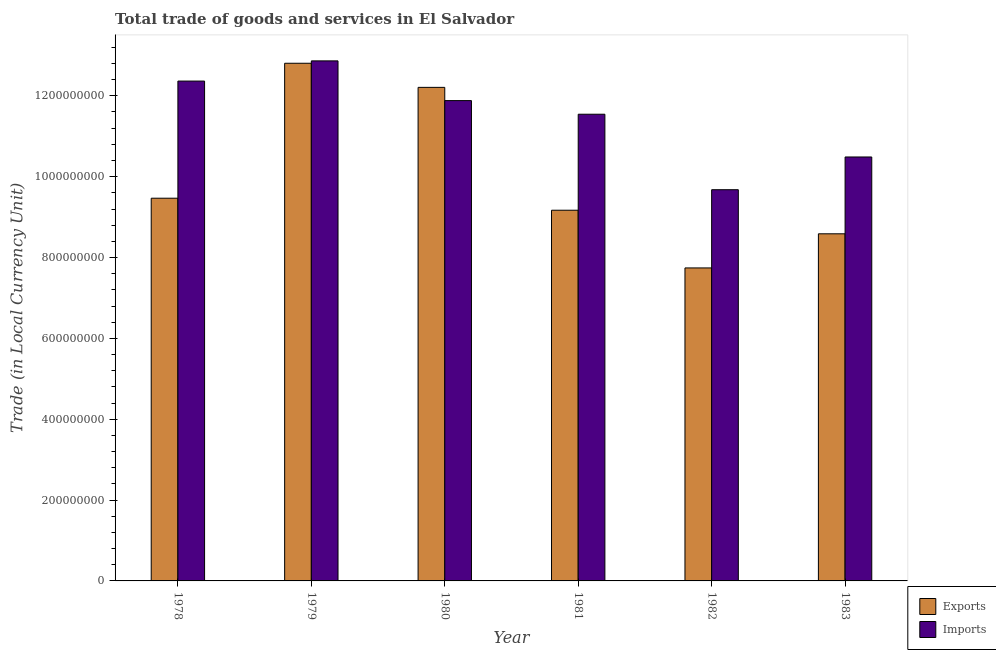How many different coloured bars are there?
Your response must be concise. 2. How many groups of bars are there?
Provide a succinct answer. 6. Are the number of bars per tick equal to the number of legend labels?
Your response must be concise. Yes. Are the number of bars on each tick of the X-axis equal?
Provide a succinct answer. Yes. How many bars are there on the 3rd tick from the right?
Your answer should be very brief. 2. What is the label of the 2nd group of bars from the left?
Provide a short and direct response. 1979. In how many cases, is the number of bars for a given year not equal to the number of legend labels?
Provide a succinct answer. 0. What is the export of goods and services in 1979?
Offer a terse response. 1.28e+09. Across all years, what is the maximum export of goods and services?
Your answer should be compact. 1.28e+09. Across all years, what is the minimum export of goods and services?
Offer a very short reply. 7.74e+08. In which year was the export of goods and services maximum?
Offer a terse response. 1979. In which year was the imports of goods and services minimum?
Make the answer very short. 1982. What is the total export of goods and services in the graph?
Offer a terse response. 6.00e+09. What is the difference between the imports of goods and services in 1978 and that in 1983?
Offer a very short reply. 1.88e+08. What is the difference between the export of goods and services in 1980 and the imports of goods and services in 1982?
Provide a succinct answer. 4.47e+08. What is the average imports of goods and services per year?
Offer a terse response. 1.15e+09. In the year 1980, what is the difference between the export of goods and services and imports of goods and services?
Offer a terse response. 0. In how many years, is the imports of goods and services greater than 240000000 LCU?
Give a very brief answer. 6. What is the ratio of the export of goods and services in 1979 to that in 1981?
Give a very brief answer. 1.4. Is the export of goods and services in 1978 less than that in 1983?
Offer a very short reply. No. What is the difference between the highest and the second highest export of goods and services?
Keep it short and to the point. 5.96e+07. What is the difference between the highest and the lowest export of goods and services?
Your response must be concise. 5.06e+08. In how many years, is the export of goods and services greater than the average export of goods and services taken over all years?
Your answer should be very brief. 2. What does the 1st bar from the left in 1978 represents?
Your answer should be very brief. Exports. What does the 1st bar from the right in 1981 represents?
Provide a succinct answer. Imports. Are all the bars in the graph horizontal?
Provide a short and direct response. No. Are the values on the major ticks of Y-axis written in scientific E-notation?
Give a very brief answer. No. How many legend labels are there?
Give a very brief answer. 2. How are the legend labels stacked?
Your response must be concise. Vertical. What is the title of the graph?
Your response must be concise. Total trade of goods and services in El Salvador. Does "Formally registered" appear as one of the legend labels in the graph?
Provide a short and direct response. No. What is the label or title of the Y-axis?
Make the answer very short. Trade (in Local Currency Unit). What is the Trade (in Local Currency Unit) in Exports in 1978?
Keep it short and to the point. 9.47e+08. What is the Trade (in Local Currency Unit) in Imports in 1978?
Offer a very short reply. 1.24e+09. What is the Trade (in Local Currency Unit) in Exports in 1979?
Keep it short and to the point. 1.28e+09. What is the Trade (in Local Currency Unit) of Imports in 1979?
Ensure brevity in your answer.  1.29e+09. What is the Trade (in Local Currency Unit) of Exports in 1980?
Your answer should be very brief. 1.22e+09. What is the Trade (in Local Currency Unit) of Imports in 1980?
Offer a terse response. 1.19e+09. What is the Trade (in Local Currency Unit) in Exports in 1981?
Make the answer very short. 9.17e+08. What is the Trade (in Local Currency Unit) in Imports in 1981?
Your answer should be compact. 1.15e+09. What is the Trade (in Local Currency Unit) in Exports in 1982?
Your answer should be compact. 7.74e+08. What is the Trade (in Local Currency Unit) of Imports in 1982?
Ensure brevity in your answer.  9.68e+08. What is the Trade (in Local Currency Unit) of Exports in 1983?
Offer a very short reply. 8.59e+08. What is the Trade (in Local Currency Unit) in Imports in 1983?
Your response must be concise. 1.05e+09. Across all years, what is the maximum Trade (in Local Currency Unit) of Exports?
Your answer should be very brief. 1.28e+09. Across all years, what is the maximum Trade (in Local Currency Unit) in Imports?
Provide a short and direct response. 1.29e+09. Across all years, what is the minimum Trade (in Local Currency Unit) of Exports?
Your answer should be compact. 7.74e+08. Across all years, what is the minimum Trade (in Local Currency Unit) of Imports?
Give a very brief answer. 9.68e+08. What is the total Trade (in Local Currency Unit) of Exports in the graph?
Make the answer very short. 6.00e+09. What is the total Trade (in Local Currency Unit) of Imports in the graph?
Give a very brief answer. 6.88e+09. What is the difference between the Trade (in Local Currency Unit) of Exports in 1978 and that in 1979?
Give a very brief answer. -3.34e+08. What is the difference between the Trade (in Local Currency Unit) in Imports in 1978 and that in 1979?
Make the answer very short. -5.00e+07. What is the difference between the Trade (in Local Currency Unit) of Exports in 1978 and that in 1980?
Keep it short and to the point. -2.74e+08. What is the difference between the Trade (in Local Currency Unit) of Imports in 1978 and that in 1980?
Make the answer very short. 4.83e+07. What is the difference between the Trade (in Local Currency Unit) in Exports in 1978 and that in 1981?
Ensure brevity in your answer.  2.97e+07. What is the difference between the Trade (in Local Currency Unit) of Imports in 1978 and that in 1981?
Keep it short and to the point. 8.20e+07. What is the difference between the Trade (in Local Currency Unit) of Exports in 1978 and that in 1982?
Provide a short and direct response. 1.72e+08. What is the difference between the Trade (in Local Currency Unit) in Imports in 1978 and that in 1982?
Make the answer very short. 2.69e+08. What is the difference between the Trade (in Local Currency Unit) in Exports in 1978 and that in 1983?
Offer a very short reply. 8.81e+07. What is the difference between the Trade (in Local Currency Unit) in Imports in 1978 and that in 1983?
Your answer should be compact. 1.88e+08. What is the difference between the Trade (in Local Currency Unit) of Exports in 1979 and that in 1980?
Ensure brevity in your answer.  5.96e+07. What is the difference between the Trade (in Local Currency Unit) of Imports in 1979 and that in 1980?
Ensure brevity in your answer.  9.83e+07. What is the difference between the Trade (in Local Currency Unit) of Exports in 1979 and that in 1981?
Provide a succinct answer. 3.64e+08. What is the difference between the Trade (in Local Currency Unit) of Imports in 1979 and that in 1981?
Keep it short and to the point. 1.32e+08. What is the difference between the Trade (in Local Currency Unit) of Exports in 1979 and that in 1982?
Give a very brief answer. 5.06e+08. What is the difference between the Trade (in Local Currency Unit) in Imports in 1979 and that in 1982?
Give a very brief answer. 3.19e+08. What is the difference between the Trade (in Local Currency Unit) in Exports in 1979 and that in 1983?
Your answer should be very brief. 4.22e+08. What is the difference between the Trade (in Local Currency Unit) in Imports in 1979 and that in 1983?
Offer a very short reply. 2.38e+08. What is the difference between the Trade (in Local Currency Unit) in Exports in 1980 and that in 1981?
Your answer should be very brief. 3.04e+08. What is the difference between the Trade (in Local Currency Unit) of Imports in 1980 and that in 1981?
Provide a succinct answer. 3.37e+07. What is the difference between the Trade (in Local Currency Unit) of Exports in 1980 and that in 1982?
Your response must be concise. 4.47e+08. What is the difference between the Trade (in Local Currency Unit) of Imports in 1980 and that in 1982?
Keep it short and to the point. 2.20e+08. What is the difference between the Trade (in Local Currency Unit) of Exports in 1980 and that in 1983?
Offer a terse response. 3.62e+08. What is the difference between the Trade (in Local Currency Unit) of Imports in 1980 and that in 1983?
Ensure brevity in your answer.  1.39e+08. What is the difference between the Trade (in Local Currency Unit) of Exports in 1981 and that in 1982?
Make the answer very short. 1.43e+08. What is the difference between the Trade (in Local Currency Unit) of Imports in 1981 and that in 1982?
Make the answer very short. 1.87e+08. What is the difference between the Trade (in Local Currency Unit) of Exports in 1981 and that in 1983?
Your answer should be compact. 5.83e+07. What is the difference between the Trade (in Local Currency Unit) in Imports in 1981 and that in 1983?
Give a very brief answer. 1.06e+08. What is the difference between the Trade (in Local Currency Unit) of Exports in 1982 and that in 1983?
Your answer should be compact. -8.44e+07. What is the difference between the Trade (in Local Currency Unit) of Imports in 1982 and that in 1983?
Provide a succinct answer. -8.10e+07. What is the difference between the Trade (in Local Currency Unit) in Exports in 1978 and the Trade (in Local Currency Unit) in Imports in 1979?
Provide a short and direct response. -3.40e+08. What is the difference between the Trade (in Local Currency Unit) of Exports in 1978 and the Trade (in Local Currency Unit) of Imports in 1980?
Keep it short and to the point. -2.41e+08. What is the difference between the Trade (in Local Currency Unit) in Exports in 1978 and the Trade (in Local Currency Unit) in Imports in 1981?
Provide a short and direct response. -2.08e+08. What is the difference between the Trade (in Local Currency Unit) in Exports in 1978 and the Trade (in Local Currency Unit) in Imports in 1982?
Your response must be concise. -2.10e+07. What is the difference between the Trade (in Local Currency Unit) of Exports in 1978 and the Trade (in Local Currency Unit) of Imports in 1983?
Offer a very short reply. -1.02e+08. What is the difference between the Trade (in Local Currency Unit) in Exports in 1979 and the Trade (in Local Currency Unit) in Imports in 1980?
Provide a short and direct response. 9.24e+07. What is the difference between the Trade (in Local Currency Unit) of Exports in 1979 and the Trade (in Local Currency Unit) of Imports in 1981?
Offer a very short reply. 1.26e+08. What is the difference between the Trade (in Local Currency Unit) of Exports in 1979 and the Trade (in Local Currency Unit) of Imports in 1982?
Offer a terse response. 3.13e+08. What is the difference between the Trade (in Local Currency Unit) in Exports in 1979 and the Trade (in Local Currency Unit) in Imports in 1983?
Provide a short and direct response. 2.32e+08. What is the difference between the Trade (in Local Currency Unit) of Exports in 1980 and the Trade (in Local Currency Unit) of Imports in 1981?
Ensure brevity in your answer.  6.64e+07. What is the difference between the Trade (in Local Currency Unit) in Exports in 1980 and the Trade (in Local Currency Unit) in Imports in 1982?
Make the answer very short. 2.53e+08. What is the difference between the Trade (in Local Currency Unit) of Exports in 1980 and the Trade (in Local Currency Unit) of Imports in 1983?
Ensure brevity in your answer.  1.72e+08. What is the difference between the Trade (in Local Currency Unit) in Exports in 1981 and the Trade (in Local Currency Unit) in Imports in 1982?
Your response must be concise. -5.08e+07. What is the difference between the Trade (in Local Currency Unit) of Exports in 1981 and the Trade (in Local Currency Unit) of Imports in 1983?
Your response must be concise. -1.32e+08. What is the difference between the Trade (in Local Currency Unit) of Exports in 1982 and the Trade (in Local Currency Unit) of Imports in 1983?
Provide a succinct answer. -2.74e+08. What is the average Trade (in Local Currency Unit) of Exports per year?
Offer a very short reply. 1.00e+09. What is the average Trade (in Local Currency Unit) in Imports per year?
Provide a short and direct response. 1.15e+09. In the year 1978, what is the difference between the Trade (in Local Currency Unit) in Exports and Trade (in Local Currency Unit) in Imports?
Provide a succinct answer. -2.90e+08. In the year 1979, what is the difference between the Trade (in Local Currency Unit) of Exports and Trade (in Local Currency Unit) of Imports?
Provide a short and direct response. -5.88e+06. In the year 1980, what is the difference between the Trade (in Local Currency Unit) in Exports and Trade (in Local Currency Unit) in Imports?
Provide a short and direct response. 3.28e+07. In the year 1981, what is the difference between the Trade (in Local Currency Unit) of Exports and Trade (in Local Currency Unit) of Imports?
Provide a succinct answer. -2.37e+08. In the year 1982, what is the difference between the Trade (in Local Currency Unit) of Exports and Trade (in Local Currency Unit) of Imports?
Your answer should be very brief. -1.94e+08. In the year 1983, what is the difference between the Trade (in Local Currency Unit) in Exports and Trade (in Local Currency Unit) in Imports?
Provide a succinct answer. -1.90e+08. What is the ratio of the Trade (in Local Currency Unit) in Exports in 1978 to that in 1979?
Offer a very short reply. 0.74. What is the ratio of the Trade (in Local Currency Unit) of Imports in 1978 to that in 1979?
Provide a short and direct response. 0.96. What is the ratio of the Trade (in Local Currency Unit) of Exports in 1978 to that in 1980?
Your answer should be very brief. 0.78. What is the ratio of the Trade (in Local Currency Unit) in Imports in 1978 to that in 1980?
Offer a terse response. 1.04. What is the ratio of the Trade (in Local Currency Unit) of Exports in 1978 to that in 1981?
Ensure brevity in your answer.  1.03. What is the ratio of the Trade (in Local Currency Unit) of Imports in 1978 to that in 1981?
Your answer should be compact. 1.07. What is the ratio of the Trade (in Local Currency Unit) of Exports in 1978 to that in 1982?
Keep it short and to the point. 1.22. What is the ratio of the Trade (in Local Currency Unit) in Imports in 1978 to that in 1982?
Your answer should be very brief. 1.28. What is the ratio of the Trade (in Local Currency Unit) in Exports in 1978 to that in 1983?
Your response must be concise. 1.1. What is the ratio of the Trade (in Local Currency Unit) in Imports in 1978 to that in 1983?
Your response must be concise. 1.18. What is the ratio of the Trade (in Local Currency Unit) in Exports in 1979 to that in 1980?
Provide a short and direct response. 1.05. What is the ratio of the Trade (in Local Currency Unit) of Imports in 1979 to that in 1980?
Offer a terse response. 1.08. What is the ratio of the Trade (in Local Currency Unit) in Exports in 1979 to that in 1981?
Your answer should be very brief. 1.4. What is the ratio of the Trade (in Local Currency Unit) in Imports in 1979 to that in 1981?
Provide a short and direct response. 1.11. What is the ratio of the Trade (in Local Currency Unit) of Exports in 1979 to that in 1982?
Offer a terse response. 1.65. What is the ratio of the Trade (in Local Currency Unit) of Imports in 1979 to that in 1982?
Your answer should be very brief. 1.33. What is the ratio of the Trade (in Local Currency Unit) of Exports in 1979 to that in 1983?
Make the answer very short. 1.49. What is the ratio of the Trade (in Local Currency Unit) of Imports in 1979 to that in 1983?
Make the answer very short. 1.23. What is the ratio of the Trade (in Local Currency Unit) of Exports in 1980 to that in 1981?
Provide a short and direct response. 1.33. What is the ratio of the Trade (in Local Currency Unit) in Imports in 1980 to that in 1981?
Provide a short and direct response. 1.03. What is the ratio of the Trade (in Local Currency Unit) of Exports in 1980 to that in 1982?
Provide a short and direct response. 1.58. What is the ratio of the Trade (in Local Currency Unit) in Imports in 1980 to that in 1982?
Ensure brevity in your answer.  1.23. What is the ratio of the Trade (in Local Currency Unit) of Exports in 1980 to that in 1983?
Your answer should be compact. 1.42. What is the ratio of the Trade (in Local Currency Unit) in Imports in 1980 to that in 1983?
Your answer should be compact. 1.13. What is the ratio of the Trade (in Local Currency Unit) in Exports in 1981 to that in 1982?
Offer a terse response. 1.18. What is the ratio of the Trade (in Local Currency Unit) in Imports in 1981 to that in 1982?
Ensure brevity in your answer.  1.19. What is the ratio of the Trade (in Local Currency Unit) in Exports in 1981 to that in 1983?
Keep it short and to the point. 1.07. What is the ratio of the Trade (in Local Currency Unit) of Imports in 1981 to that in 1983?
Make the answer very short. 1.1. What is the ratio of the Trade (in Local Currency Unit) of Exports in 1982 to that in 1983?
Provide a short and direct response. 0.9. What is the ratio of the Trade (in Local Currency Unit) in Imports in 1982 to that in 1983?
Your answer should be compact. 0.92. What is the difference between the highest and the second highest Trade (in Local Currency Unit) of Exports?
Your response must be concise. 5.96e+07. What is the difference between the highest and the second highest Trade (in Local Currency Unit) of Imports?
Give a very brief answer. 5.00e+07. What is the difference between the highest and the lowest Trade (in Local Currency Unit) in Exports?
Provide a short and direct response. 5.06e+08. What is the difference between the highest and the lowest Trade (in Local Currency Unit) of Imports?
Your answer should be very brief. 3.19e+08. 